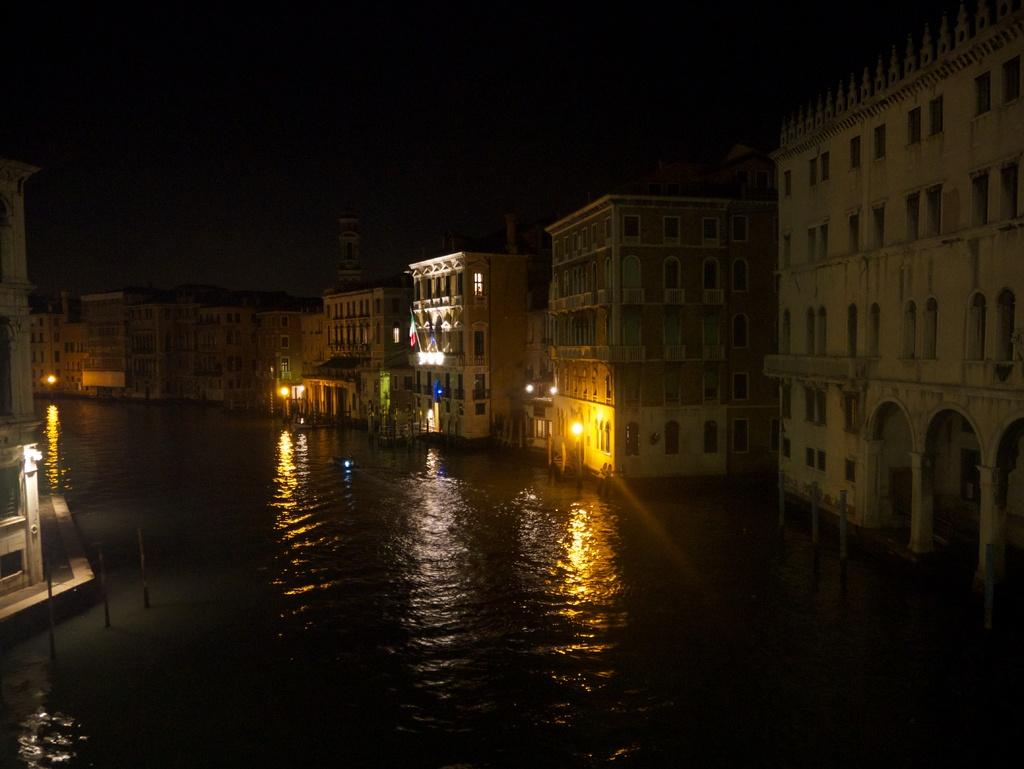What is the main feature in the center of the image? There is water in the center of the image. What can be seen on the right side of the image? There are buildings on the right side of the image. What is located on the left side of the image? There is a building on the left side of the image, and there are also poles present. What type of jeans are being exchanged in the square in the image? There is no square, jeans, or exchange of any kind depicted in the image. 